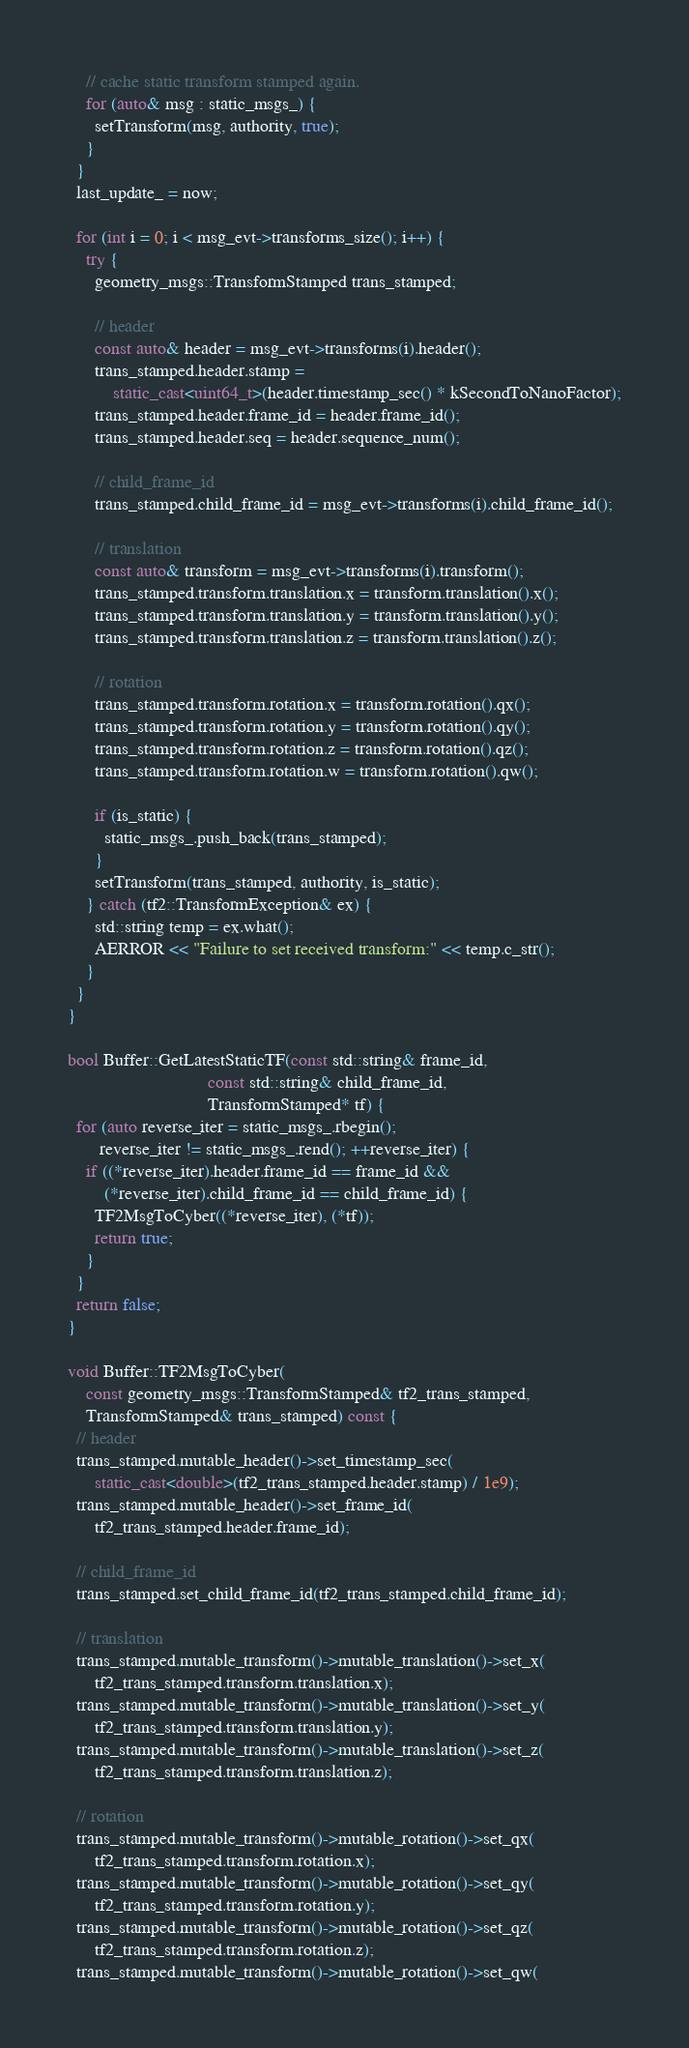<code> <loc_0><loc_0><loc_500><loc_500><_C++_>    // cache static transform stamped again.
    for (auto& msg : static_msgs_) {
      setTransform(msg, authority, true);
    }
  }
  last_update_ = now;

  for (int i = 0; i < msg_evt->transforms_size(); i++) {
    try {
      geometry_msgs::TransformStamped trans_stamped;

      // header
      const auto& header = msg_evt->transforms(i).header();
      trans_stamped.header.stamp =
          static_cast<uint64_t>(header.timestamp_sec() * kSecondToNanoFactor);
      trans_stamped.header.frame_id = header.frame_id();
      trans_stamped.header.seq = header.sequence_num();

      // child_frame_id
      trans_stamped.child_frame_id = msg_evt->transforms(i).child_frame_id();

      // translation
      const auto& transform = msg_evt->transforms(i).transform();
      trans_stamped.transform.translation.x = transform.translation().x();
      trans_stamped.transform.translation.y = transform.translation().y();
      trans_stamped.transform.translation.z = transform.translation().z();

      // rotation
      trans_stamped.transform.rotation.x = transform.rotation().qx();
      trans_stamped.transform.rotation.y = transform.rotation().qy();
      trans_stamped.transform.rotation.z = transform.rotation().qz();
      trans_stamped.transform.rotation.w = transform.rotation().qw();

      if (is_static) {
        static_msgs_.push_back(trans_stamped);
      }
      setTransform(trans_stamped, authority, is_static);
    } catch (tf2::TransformException& ex) {
      std::string temp = ex.what();
      AERROR << "Failure to set received transform:" << temp.c_str();
    }
  }
}

bool Buffer::GetLatestStaticTF(const std::string& frame_id,
                               const std::string& child_frame_id,
                               TransformStamped* tf) {
  for (auto reverse_iter = static_msgs_.rbegin();
       reverse_iter != static_msgs_.rend(); ++reverse_iter) {
    if ((*reverse_iter).header.frame_id == frame_id &&
        (*reverse_iter).child_frame_id == child_frame_id) {
      TF2MsgToCyber((*reverse_iter), (*tf));
      return true;
    }
  }
  return false;
}

void Buffer::TF2MsgToCyber(
    const geometry_msgs::TransformStamped& tf2_trans_stamped,
    TransformStamped& trans_stamped) const {
  // header
  trans_stamped.mutable_header()->set_timestamp_sec(
      static_cast<double>(tf2_trans_stamped.header.stamp) / 1e9);
  trans_stamped.mutable_header()->set_frame_id(
      tf2_trans_stamped.header.frame_id);

  // child_frame_id
  trans_stamped.set_child_frame_id(tf2_trans_stamped.child_frame_id);

  // translation
  trans_stamped.mutable_transform()->mutable_translation()->set_x(
      tf2_trans_stamped.transform.translation.x);
  trans_stamped.mutable_transform()->mutable_translation()->set_y(
      tf2_trans_stamped.transform.translation.y);
  trans_stamped.mutable_transform()->mutable_translation()->set_z(
      tf2_trans_stamped.transform.translation.z);

  // rotation
  trans_stamped.mutable_transform()->mutable_rotation()->set_qx(
      tf2_trans_stamped.transform.rotation.x);
  trans_stamped.mutable_transform()->mutable_rotation()->set_qy(
      tf2_trans_stamped.transform.rotation.y);
  trans_stamped.mutable_transform()->mutable_rotation()->set_qz(
      tf2_trans_stamped.transform.rotation.z);
  trans_stamped.mutable_transform()->mutable_rotation()->set_qw(</code> 